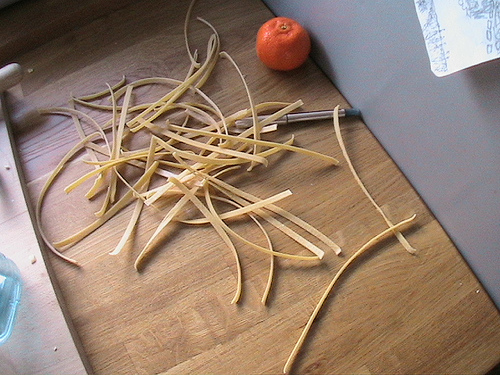<image>
Is the table under the orange? Yes. The table is positioned underneath the orange, with the orange above it in the vertical space. Is the pen in the noodle? Yes. The pen is contained within or inside the noodle, showing a containment relationship. 